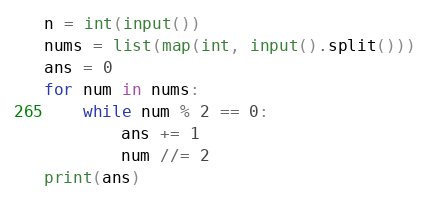<code> <loc_0><loc_0><loc_500><loc_500><_Python_>n = int(input())
nums = list(map(int, input().split()))
ans = 0
for num in nums:
    while num % 2 == 0:
        ans += 1
        num //= 2
print(ans)</code> 